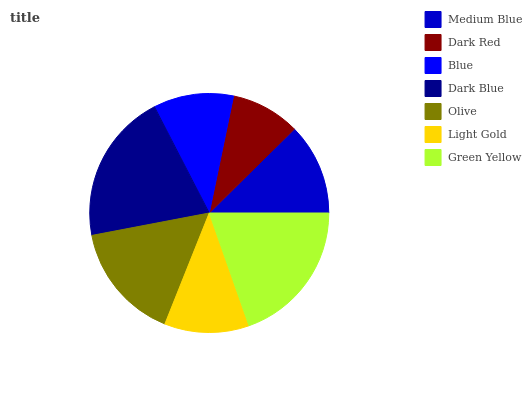Is Dark Red the minimum?
Answer yes or no. Yes. Is Dark Blue the maximum?
Answer yes or no. Yes. Is Blue the minimum?
Answer yes or no. No. Is Blue the maximum?
Answer yes or no. No. Is Blue greater than Dark Red?
Answer yes or no. Yes. Is Dark Red less than Blue?
Answer yes or no. Yes. Is Dark Red greater than Blue?
Answer yes or no. No. Is Blue less than Dark Red?
Answer yes or no. No. Is Medium Blue the high median?
Answer yes or no. Yes. Is Medium Blue the low median?
Answer yes or no. Yes. Is Olive the high median?
Answer yes or no. No. Is Blue the low median?
Answer yes or no. No. 